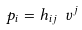Convert formula to latex. <formula><loc_0><loc_0><loc_500><loc_500>p _ { i } = h _ { i j } \ v ^ { j }</formula> 